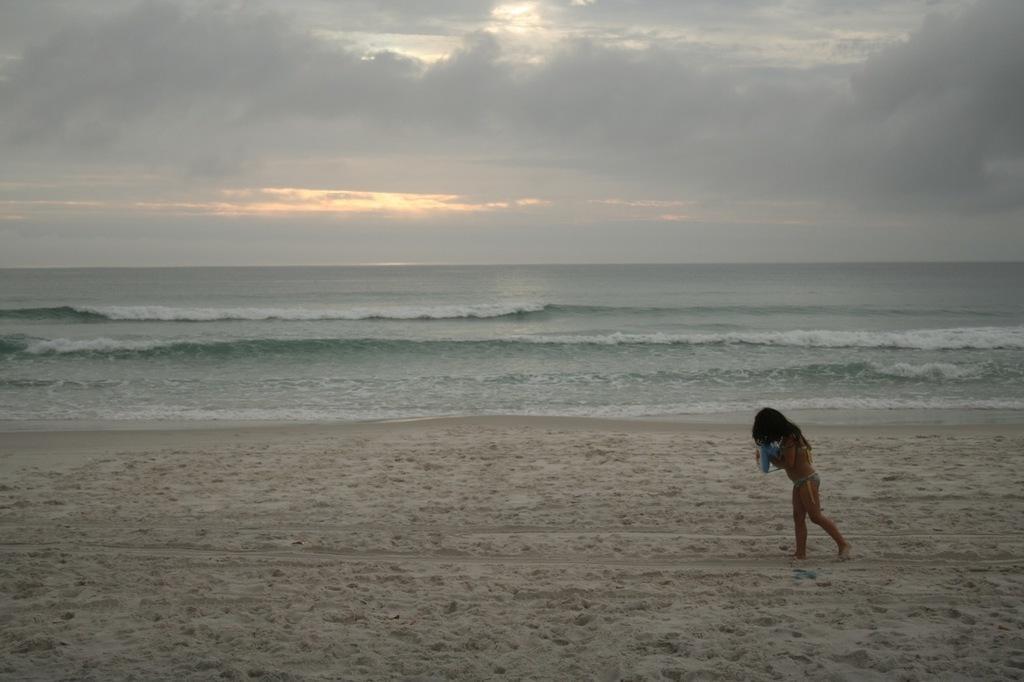Describe this image in one or two sentences. In this image I can see a woman is walking on the right side. I can also see sand in the front and in the background I can see water, clouds and the sky. 